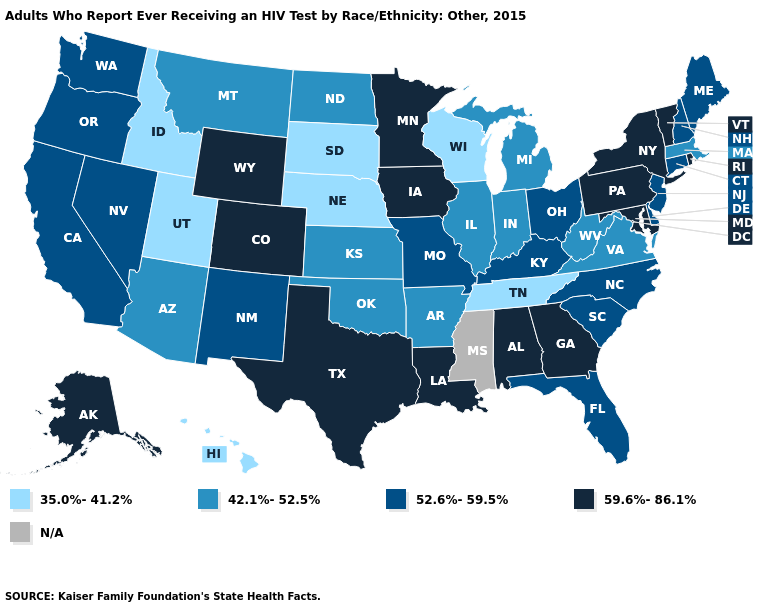Name the states that have a value in the range N/A?
Quick response, please. Mississippi. Name the states that have a value in the range 59.6%-86.1%?
Concise answer only. Alabama, Alaska, Colorado, Georgia, Iowa, Louisiana, Maryland, Minnesota, New York, Pennsylvania, Rhode Island, Texas, Vermont, Wyoming. Does Kentucky have the highest value in the South?
Answer briefly. No. Which states have the highest value in the USA?
Short answer required. Alabama, Alaska, Colorado, Georgia, Iowa, Louisiana, Maryland, Minnesota, New York, Pennsylvania, Rhode Island, Texas, Vermont, Wyoming. Is the legend a continuous bar?
Concise answer only. No. What is the value of Georgia?
Concise answer only. 59.6%-86.1%. What is the lowest value in the MidWest?
Quick response, please. 35.0%-41.2%. Name the states that have a value in the range 59.6%-86.1%?
Be succinct. Alabama, Alaska, Colorado, Georgia, Iowa, Louisiana, Maryland, Minnesota, New York, Pennsylvania, Rhode Island, Texas, Vermont, Wyoming. What is the value of Illinois?
Quick response, please. 42.1%-52.5%. Name the states that have a value in the range 59.6%-86.1%?
Answer briefly. Alabama, Alaska, Colorado, Georgia, Iowa, Louisiana, Maryland, Minnesota, New York, Pennsylvania, Rhode Island, Texas, Vermont, Wyoming. Which states have the lowest value in the USA?
Give a very brief answer. Hawaii, Idaho, Nebraska, South Dakota, Tennessee, Utah, Wisconsin. What is the highest value in the MidWest ?
Short answer required. 59.6%-86.1%. What is the lowest value in the Northeast?
Write a very short answer. 42.1%-52.5%. What is the highest value in the South ?
Concise answer only. 59.6%-86.1%. 